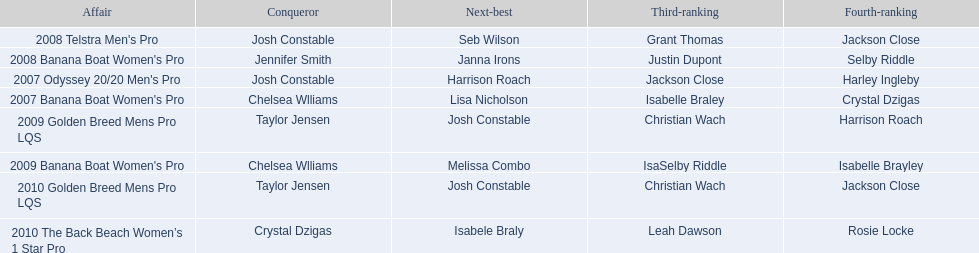What is the number of occasions on which josh constable finished in second place? 2. 